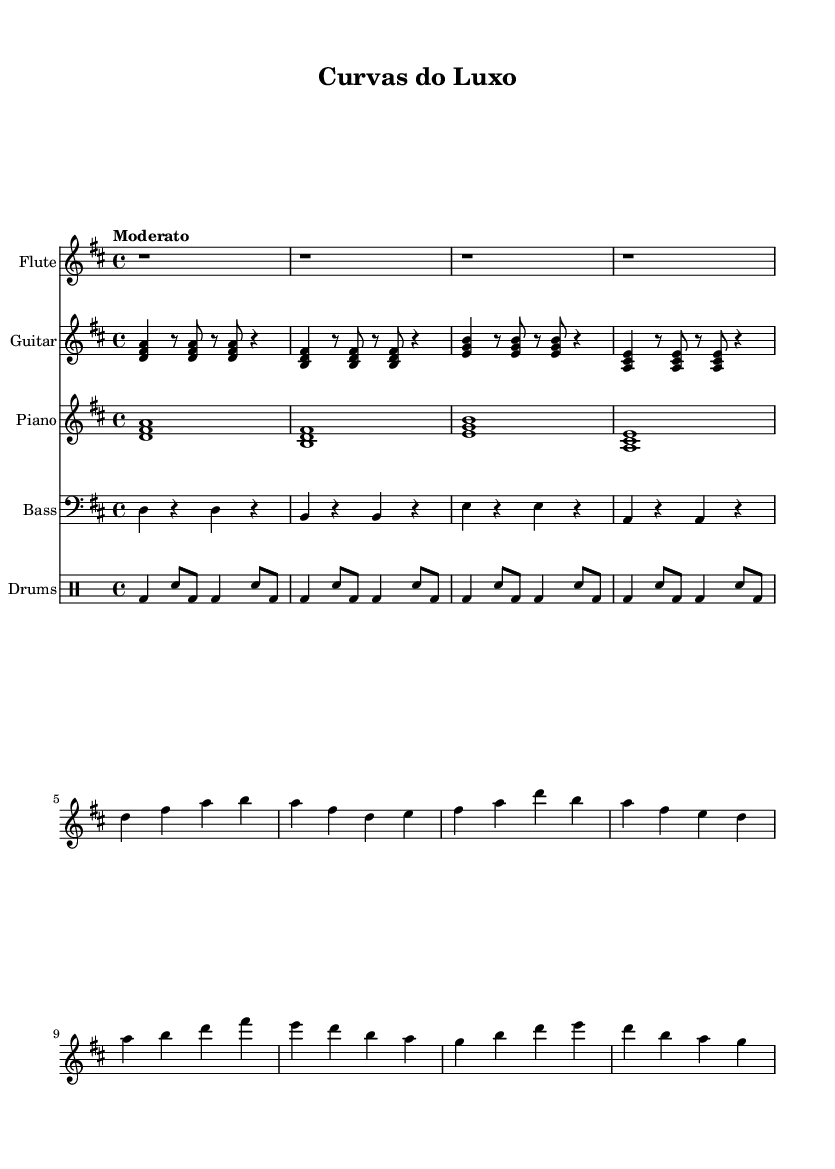What is the key signature of this music? The key signature is indicated at the beginning of the staff. It shows two sharps, which means the key is D major.
Answer: D major What is the time signature of the music? The time signature appears after the key signature and is represented as 4/4. This indicates that there are four beats in each measure, and the quarter note gets one beat.
Answer: 4/4 What is the tempo marking for this piece? The tempo marking is located just above the music staff, stating "Moderato," which indicates a moderate pace.
Answer: Moderato How many measures are in the flute part? To find the number of measures, we count the bars indicated in the flute part. There are a total of four measures in the flute section.
Answer: 4 What instruments are featured in this music? The instrument names are listed at the beginning of each staff. The music features Flute, Guitar, Piano, Bass, and Drums.
Answer: Flute, Guitar, Piano, Bass, Drums Which measure contains the highest note in the flute part? By examining the flute part, we can see that the highest note is A, which appears in measure 5.
Answer: Measure 5 What is the rhythmic pattern used in the drums? The rhythmic pattern is evident in the notated drum part, showcasing a consistent pattern of bass drums and snare hits. The pattern includes a combination of quarter notes and eighth notes.
Answer: Bass and snare pattern 